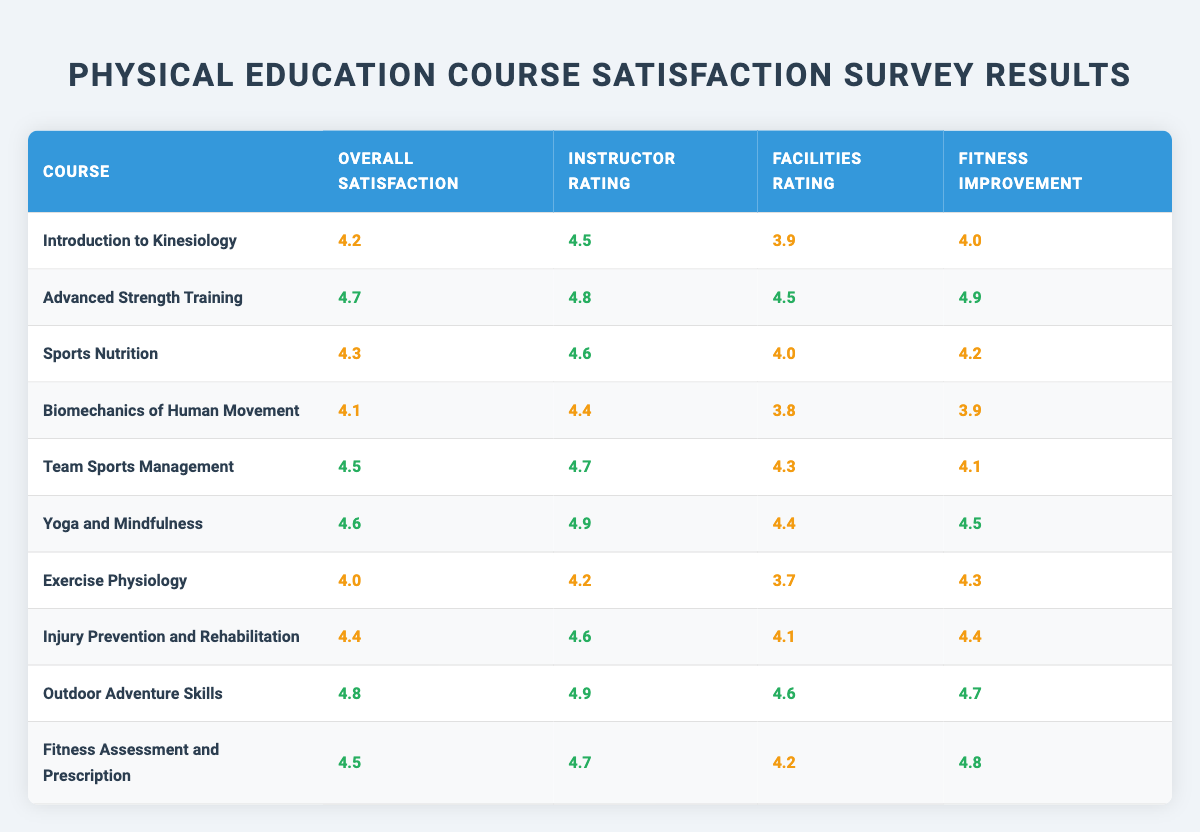What is the overall satisfaction rating for Outdoor Adventure Skills? The overall satisfaction rating can be found by looking at the row for Outdoor Adventure Skills. It is listed as 4.8.
Answer: 4.8 Which course received the highest instructor rating? By examining the instructor ratings for all the courses, Advanced Strength Training, Yoga and Mindfulness, and Outdoor Adventure Skills all received a rating of 4.9, which is the highest value.
Answer: Advanced Strength Training, Yoga and Mindfulness, Outdoor Adventure Skills What is the average overall satisfaction rating of the courses? To find the average, add all the overall satisfaction ratings and divide by the number of courses: (4.2 + 4.7 + 4.3 + 4.1 + 4.5 + 4.6 + 4.0 + 4.4 + 4.8 + 4.5) = 44.2 and 44.2 divided by 10 equals 4.42.
Answer: 4.42 Is the Facilities Rating for Injury Prevention and Rehabilitation greater than the Fitness Improvement rating for the same course? The Facilities Rating for Injury Prevention and Rehabilitation is 4.1 and the Fitness Improvement rating is 4.4. Since 4.1 is less than 4.4, the statement is false.
Answer: No Which course has the largest difference between its Instructor Rating and its Facilities Rating? Calculate the difference for each course by subtracting Facilities Rating from Instructor Rating. For example, for Advanced Strength Training: 4.8 - 4.5 = 0.3. After calculating for all courses, the largest difference is found in Exercise Physiology: 4.2 - 3.7 = 0.5.
Answer: Exercise Physiology Does Team Sports Management have a higher Overall Satisfaction than Sports Nutrition? The Overall Satisfaction for Team Sports Management is 4.5, and for Sports Nutrition, it is 4.3. Since 4.5 is greater than 4.3, this statement is true.
Answer: Yes What is the combined Fitness Improvement rating for Yoga and Mindfulness and Fitness Assessment and Prescription courses? The Fitness Improvement rating for Yoga and Mindfulness is 4.5 and for Fitness Assessment and Prescription is 4.8. Adding these two together gives 4.5 + 4.8 = 9.3.
Answer: 9.3 Which two courses have the same Overall Satisfaction rating of 4.5? By scanning through the table, I find that Advanced Strength Training and Fitness Assessment and Prescription both share the Overall Satisfaction rating of 4.5.
Answer: Advanced Strength Training, Fitness Assessment and Prescription What is the lowest rated Facilities Rating among these courses? By reviewing the Facilities Ratings across all courses, the lowest value is 3.7 from Exercise Physiology, which can be directly noted from the table.
Answer: 3.7 